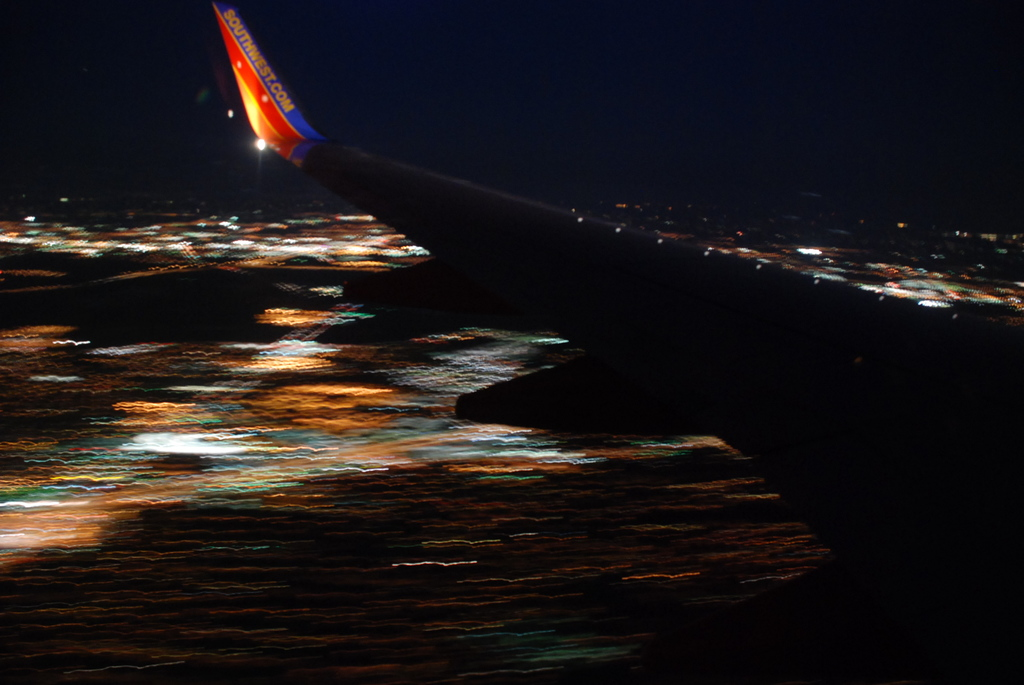Provide a one-sentence caption for the provided image.
Reference OCR token:  a blurred landing of a Southwest flight where only the wing is visible. 